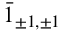<formula> <loc_0><loc_0><loc_500><loc_500>\bar { 1 } _ { \pm 1 , \pm 1 }</formula> 